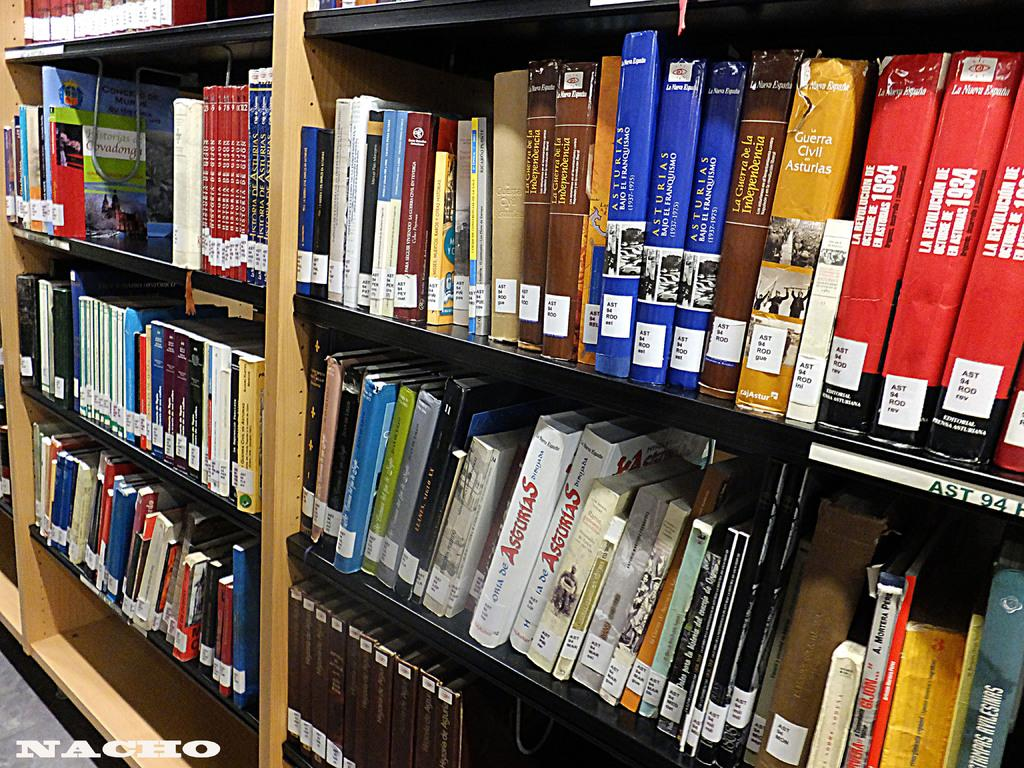<image>
Share a concise interpretation of the image provided. A bunch of books on a library shelf that includes Asturias books. 